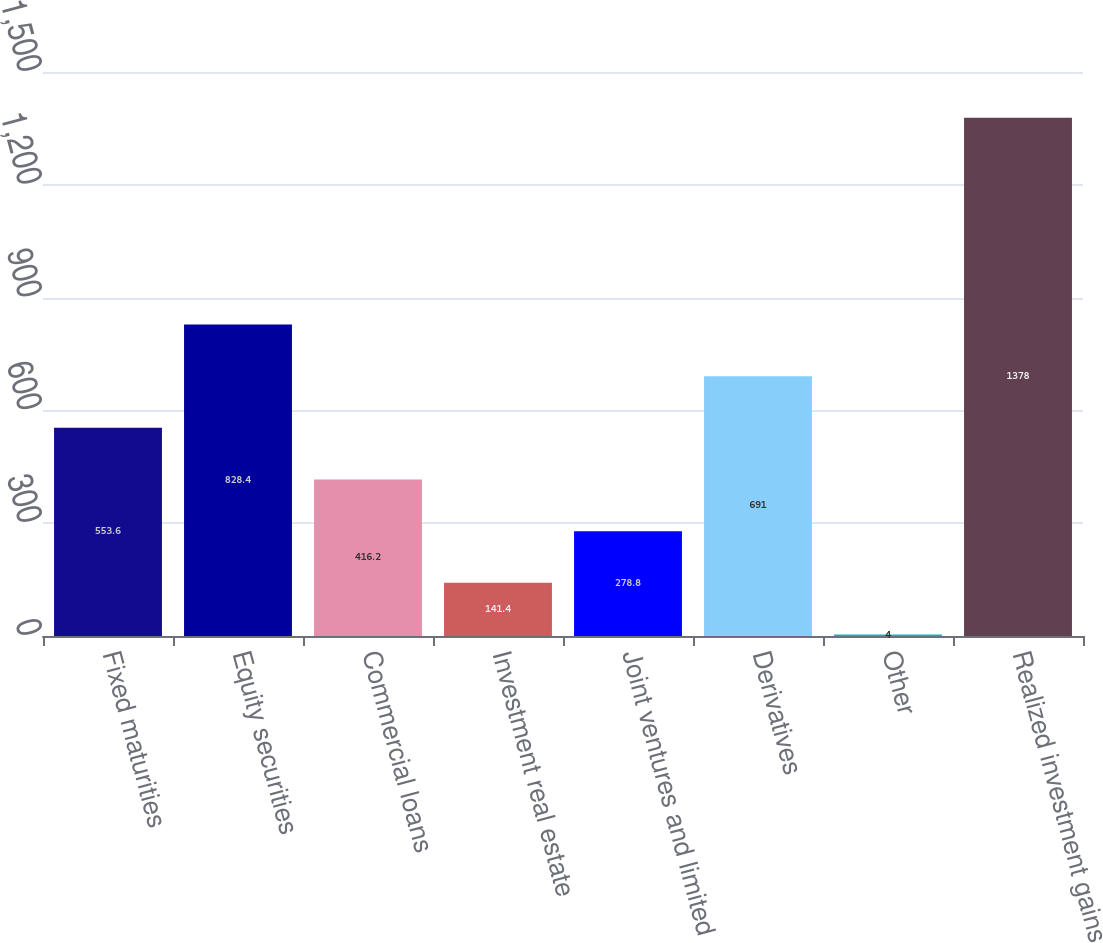<chart> <loc_0><loc_0><loc_500><loc_500><bar_chart><fcel>Fixed maturities<fcel>Equity securities<fcel>Commercial loans<fcel>Investment real estate<fcel>Joint ventures and limited<fcel>Derivatives<fcel>Other<fcel>Realized investment gains<nl><fcel>553.6<fcel>828.4<fcel>416.2<fcel>141.4<fcel>278.8<fcel>691<fcel>4<fcel>1378<nl></chart> 